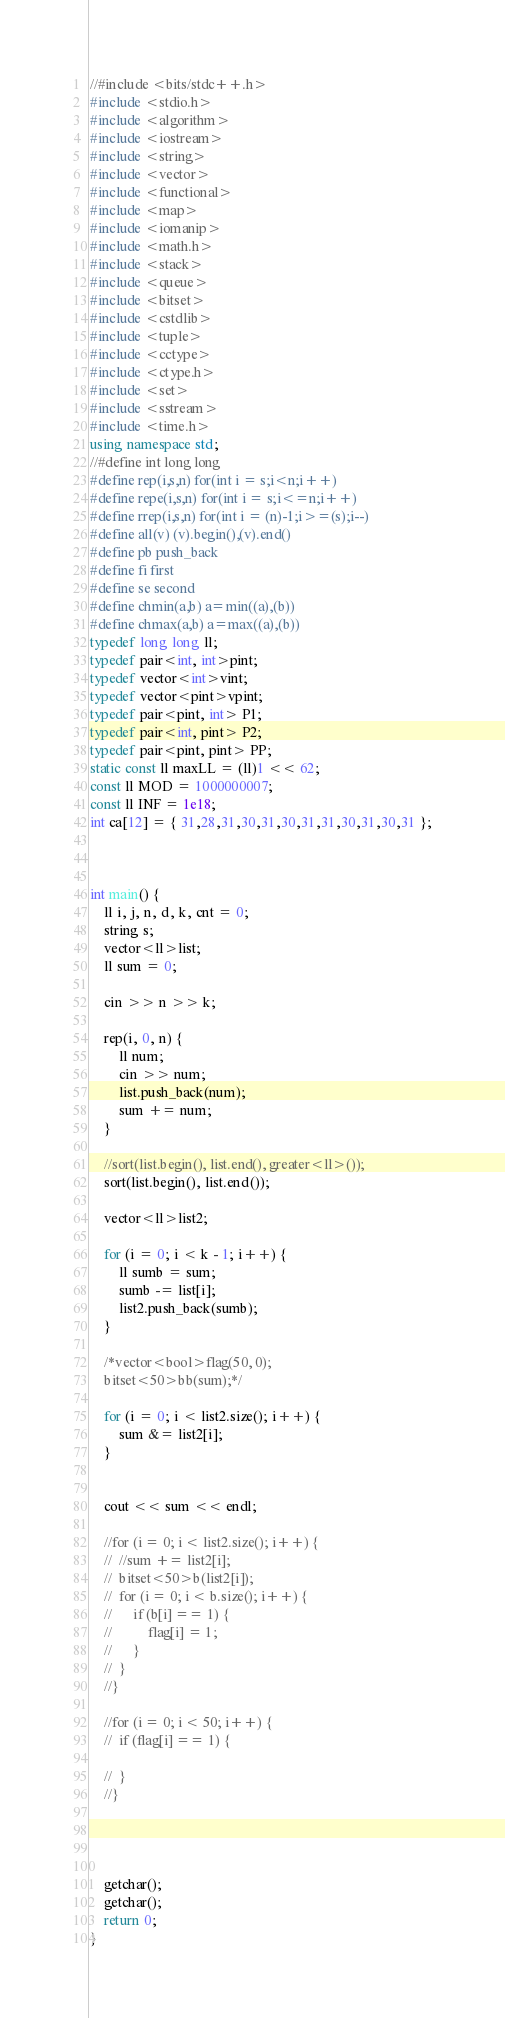<code> <loc_0><loc_0><loc_500><loc_500><_C++_>//#include <bits/stdc++.h>
#include <stdio.h>
#include <algorithm>
#include <iostream>
#include <string>
#include <vector>
#include <functional>
#include <map>
#include <iomanip>
#include <math.h> 
#include <stack>
#include <queue>
#include <bitset>
#include <cstdlib>
#include <tuple>
#include <cctype>
#include <ctype.h>
#include <set>
#include <sstream>
#include <time.h>
using namespace std;
//#define int long long
#define rep(i,s,n) for(int i = s;i<n;i++)
#define repe(i,s,n) for(int i = s;i<=n;i++)
#define rrep(i,s,n) for(int i = (n)-1;i>=(s);i--)
#define all(v) (v).begin(),(v).end()
#define pb push_back
#define fi first
#define se second
#define chmin(a,b) a=min((a),(b))
#define chmax(a,b) a=max((a),(b))
typedef long long ll;
typedef pair<int, int>pint;
typedef vector<int>vint;
typedef vector<pint>vpint;
typedef pair<pint, int> P1;
typedef pair<int, pint> P2;
typedef pair<pint, pint> PP;
static const ll maxLL = (ll)1 << 62;
const ll MOD = 1000000007;
const ll INF = 1e18;
int ca[12] = { 31,28,31,30,31,30,31,31,30,31,30,31 };



int main() {
	ll i, j, n, d, k, cnt = 0;
	string s;
	vector<ll>list;
	ll sum = 0;

	cin >> n >> k;

	rep(i, 0, n) {
		ll num;
		cin >> num;
		list.push_back(num);
		sum += num;
	}
	
	//sort(list.begin(), list.end(), greater<ll>());
	sort(list.begin(), list.end());
	
	vector<ll>list2;

	for (i = 0; i < k - 1; i++) {
		ll sumb = sum;
		sumb -= list[i];
		list2.push_back(sumb);
	}

	/*vector<bool>flag(50, 0);
	bitset<50>bb(sum);*/

	for (i = 0; i < list2.size(); i++) {
		sum &= list2[i];
	}


	cout << sum << endl;

	//for (i = 0; i < list2.size(); i++) {
	//	//sum += list2[i];
	//	bitset<50>b(list2[i]);
	//	for (i = 0; i < b.size(); i++) {
	//		if (b[i] == 1) {
	//			flag[i] = 1;
	//		}
	//	}
	//}

	//for (i = 0; i < 50; i++) {
	//	if (flag[i] == 1) {

	//	}
	//}




	getchar();
	getchar();
	return 0;
}</code> 